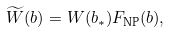<formula> <loc_0><loc_0><loc_500><loc_500>\widetilde { W } ( b ) = W ( b _ { * } ) F _ { \text {NP} } ( b ) ,</formula> 